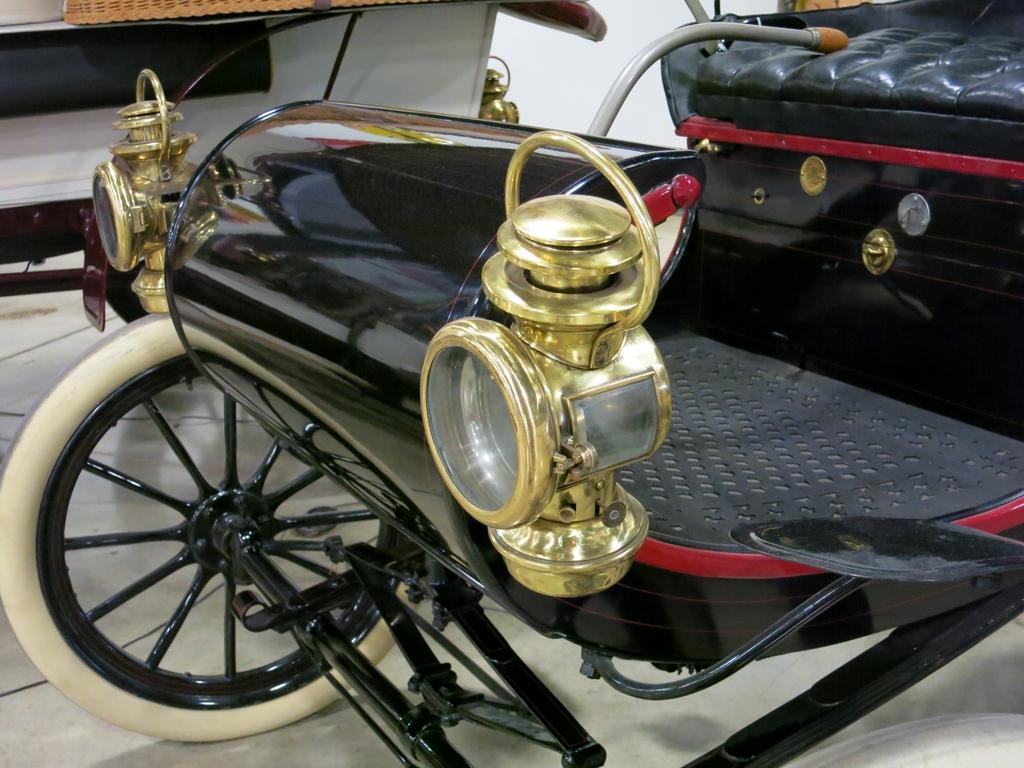Could you give a brief overview of what you see in this image? This image is taken indoors. At the bottom of the image there is a floor. In the middle of the image two vehicles are parked on the floor. 